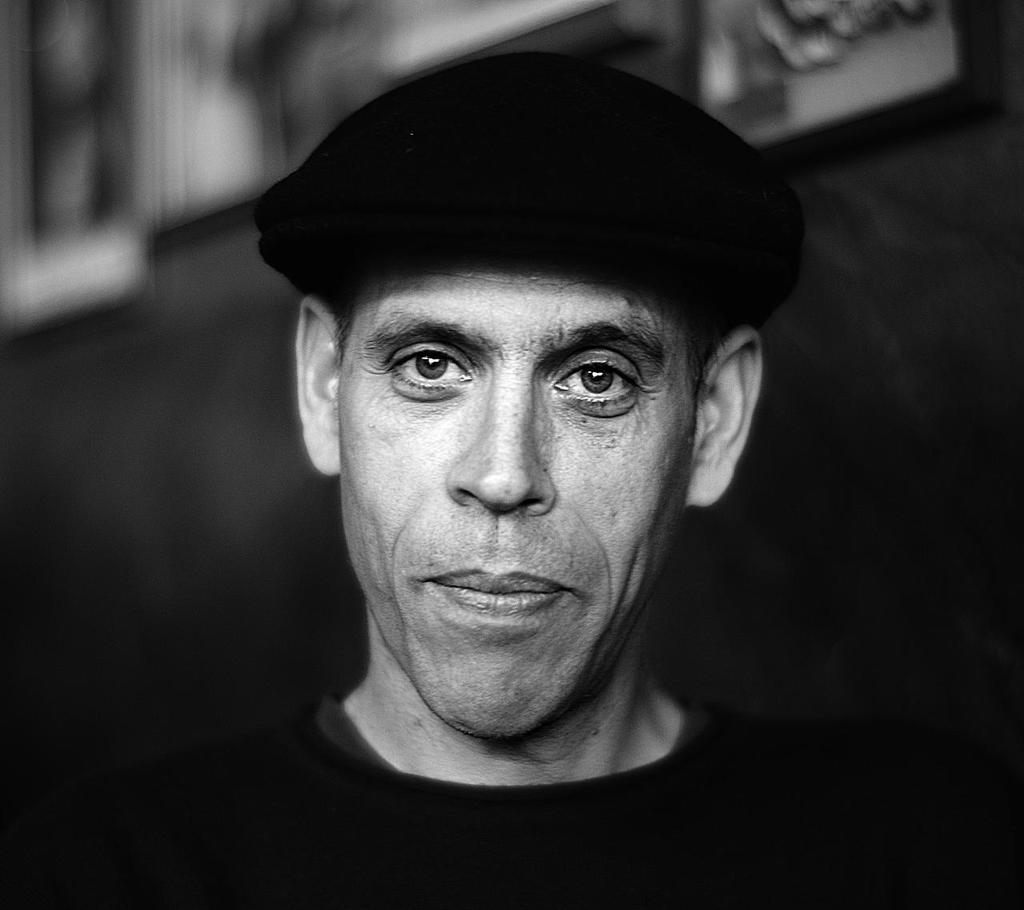Who or what is the main subject in the image? There is a person in the image. What is the person doing in the image? The person is facing the camera. What can be seen on the person's head in the image? The person is wearing a black hat. What type of instrument is the person playing in the image? There is no instrument present in the image, and the person is not shown playing any instrument. 